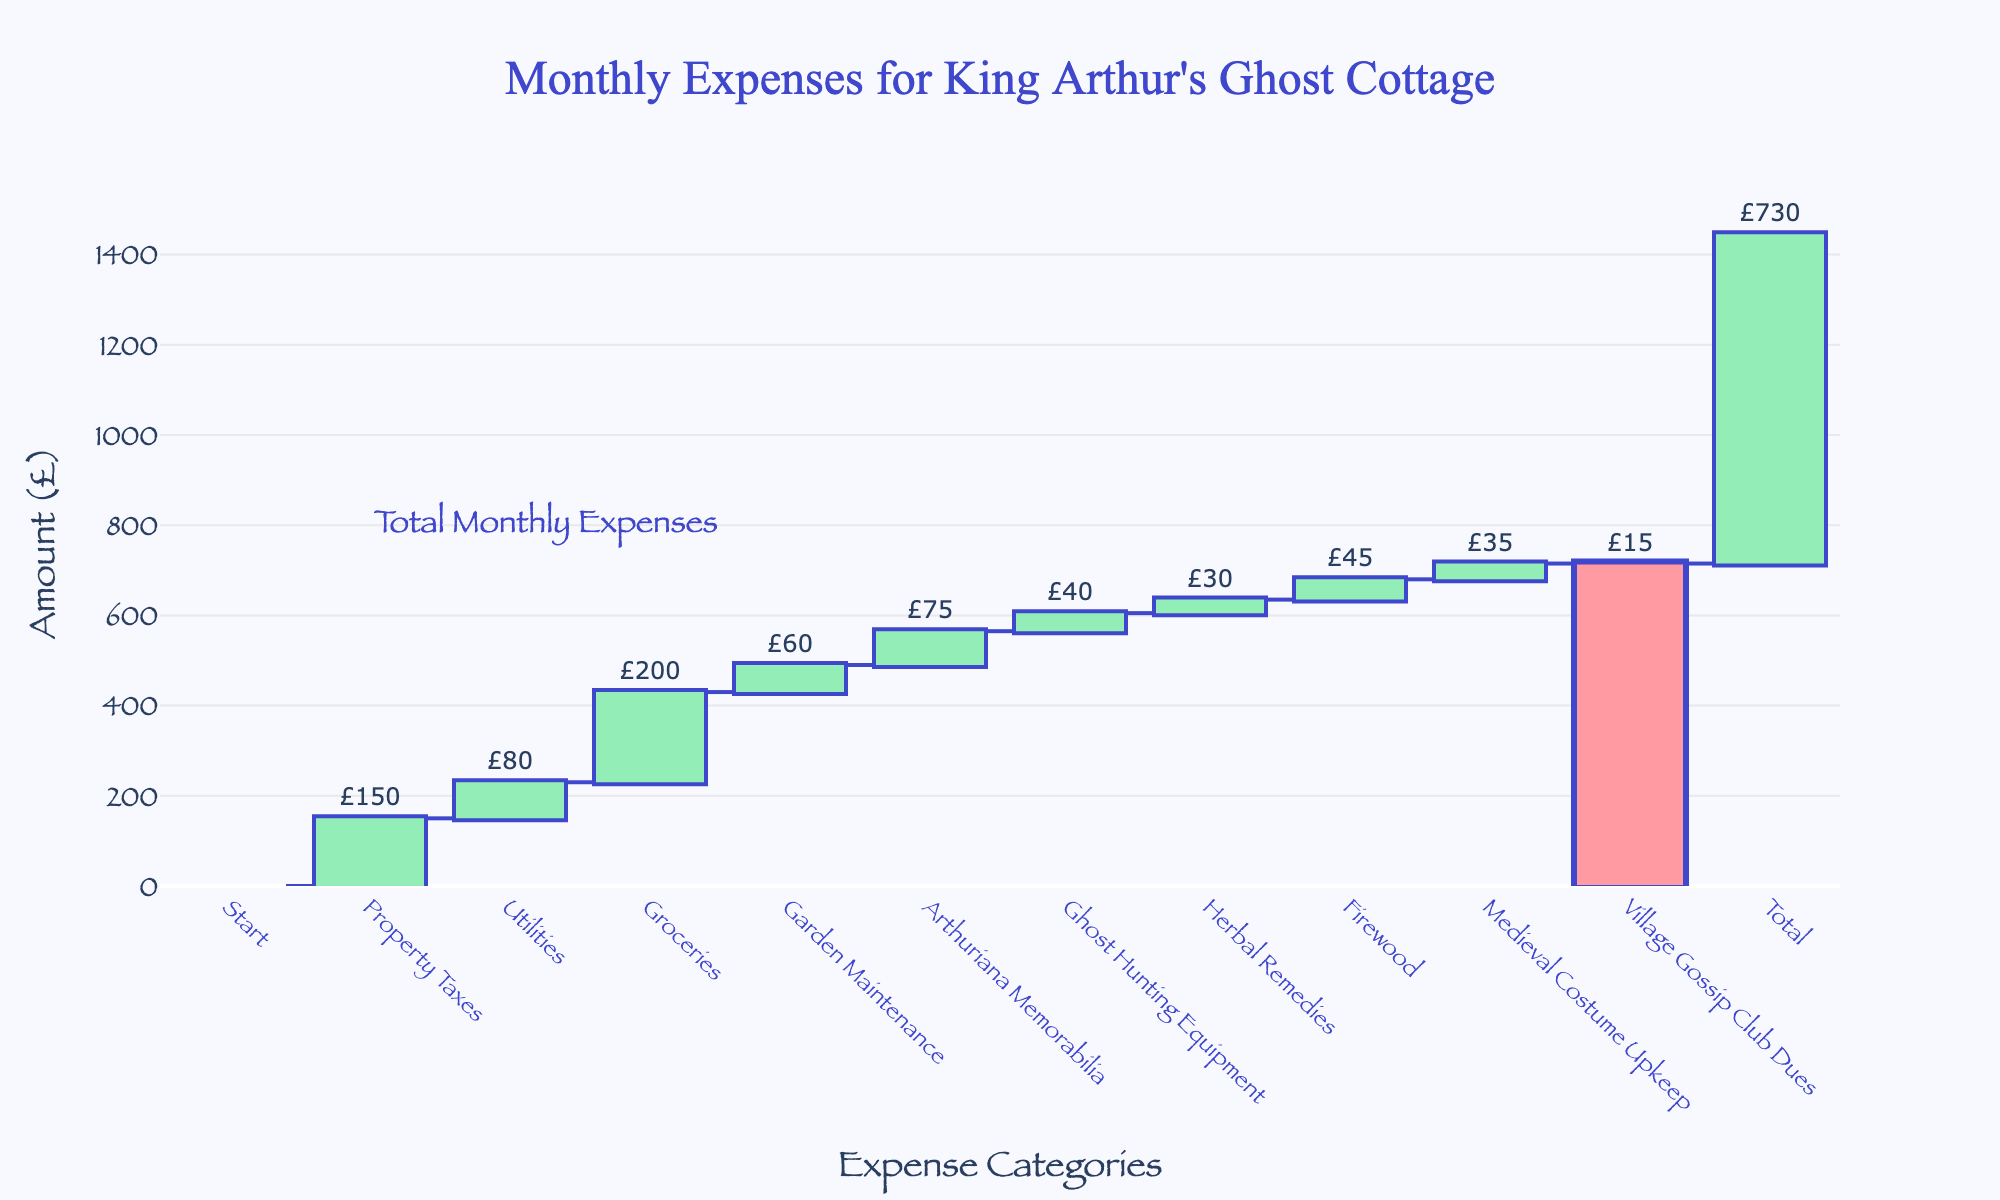What's the title of the chart? The title is located at the top of the chart. It indicates what the chart is illustrating.
Answer: Monthly Expenses for King Arthur's Ghost Cottage What is the amount spent on groceries? The "Groceries" data point can be found on the x-axis, and the corresponding value is marked above the bar.
Answer: £200 Which category has the smallest expense? By examining all the values associated with the categories, "Village Gossip Club Dues" has the smallest number.
Answer: Village Gossip Club Dues What is the cumulative expense after Arthuriana Memorabilia? Locate "Arthuriana Memorabilia" on the x-axis and observe the cumulative bar just after this point.
Answer: £565 What is the total monthly expense? The total expense is indicated at the far right of the chart as the final value.
Answer: £730 How much more is spent on groceries compared to garden maintenance? Check the values for "Groceries" (£200) and "Garden Maintenance" (£60). Subtract the smaller amount from the larger one to find the difference.
Answer: £140 How many categories have expenses greater than £50? Identify and count each category with expenses over £50 by visually inspecting the bars and labels.
Answer: 5 What is the combined expense for Firewood and Medieval Costume Upkeep? Find the expenses for "Firewood" (£45) and "Medieval Costume Upkeep" (£35). Add these two amounts together.
Answer: £80 What are the two highest expenses? Compare the values of all categories and identify the two highest expenses, which are "Groceries" and "Property Taxes".
Answer: Groceries and Property Taxes Is the amount spent on ghost hunting equipment more than on herbal remedies? Compare the two values directly from the chart: "Ghost Hunting Equipment" (£40) and "Herbal Remedies" (£30).
Answer: Yes 